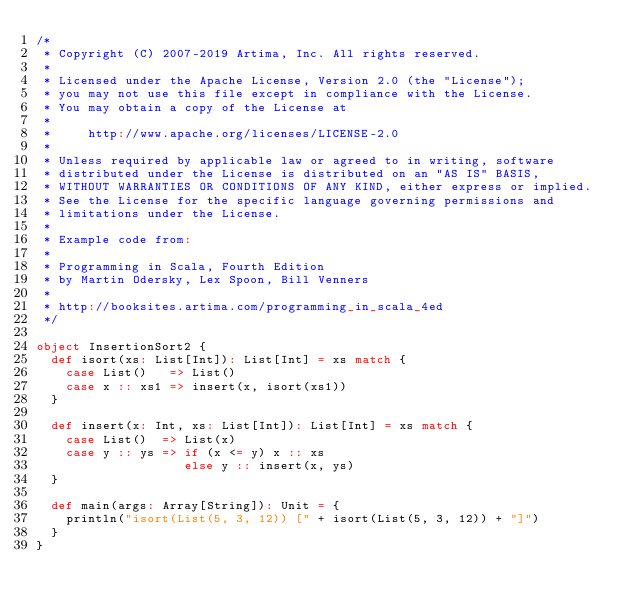Convert code to text. <code><loc_0><loc_0><loc_500><loc_500><_Scala_>/*
 * Copyright (C) 2007-2019 Artima, Inc. All rights reserved.
 * 
 * Licensed under the Apache License, Version 2.0 (the "License");
 * you may not use this file except in compliance with the License.
 * You may obtain a copy of the License at
 * 
 *     http://www.apache.org/licenses/LICENSE-2.0
 * 
 * Unless required by applicable law or agreed to in writing, software
 * distributed under the License is distributed on an "AS IS" BASIS,
 * WITHOUT WARRANTIES OR CONDITIONS OF ANY KIND, either express or implied.
 * See the License for the specific language governing permissions and
 * limitations under the License.
 *
 * Example code from:
 *
 * Programming in Scala, Fourth Edition
 * by Martin Odersky, Lex Spoon, Bill Venners
 *
 * http://booksites.artima.com/programming_in_scala_4ed
 */

object InsertionSort2 {
  def isort(xs: List[Int]): List[Int] = xs match {
    case List()   => List()
    case x :: xs1 => insert(x, isort(xs1))
  }
  
  def insert(x: Int, xs: List[Int]): List[Int] = xs match {
    case List()  => List(x)
    case y :: ys => if (x <= y) x :: xs 
                    else y :: insert(x, ys)
  }

  def main(args: Array[String]): Unit = {
    println("isort(List(5, 3, 12)) [" + isort(List(5, 3, 12)) + "]")
  }
}
</code> 